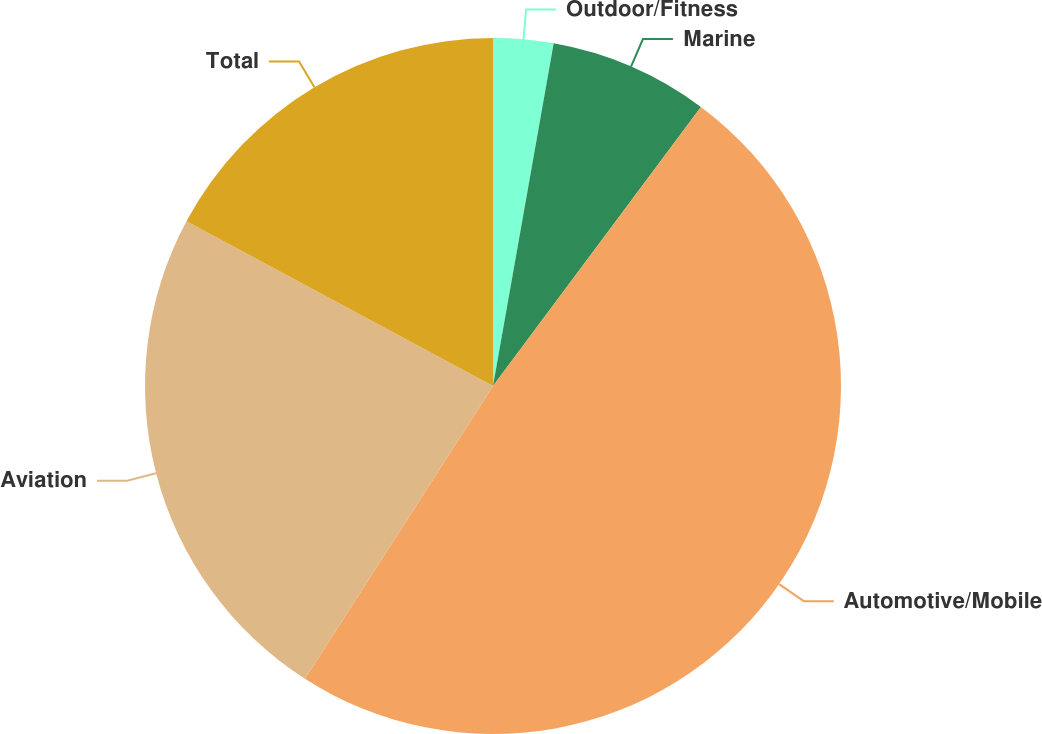Convert chart to OTSL. <chart><loc_0><loc_0><loc_500><loc_500><pie_chart><fcel>Outdoor/Fitness<fcel>Marine<fcel>Automotive/Mobile<fcel>Aviation<fcel>Total<nl><fcel>2.79%<fcel>7.4%<fcel>48.89%<fcel>23.76%<fcel>17.15%<nl></chart> 